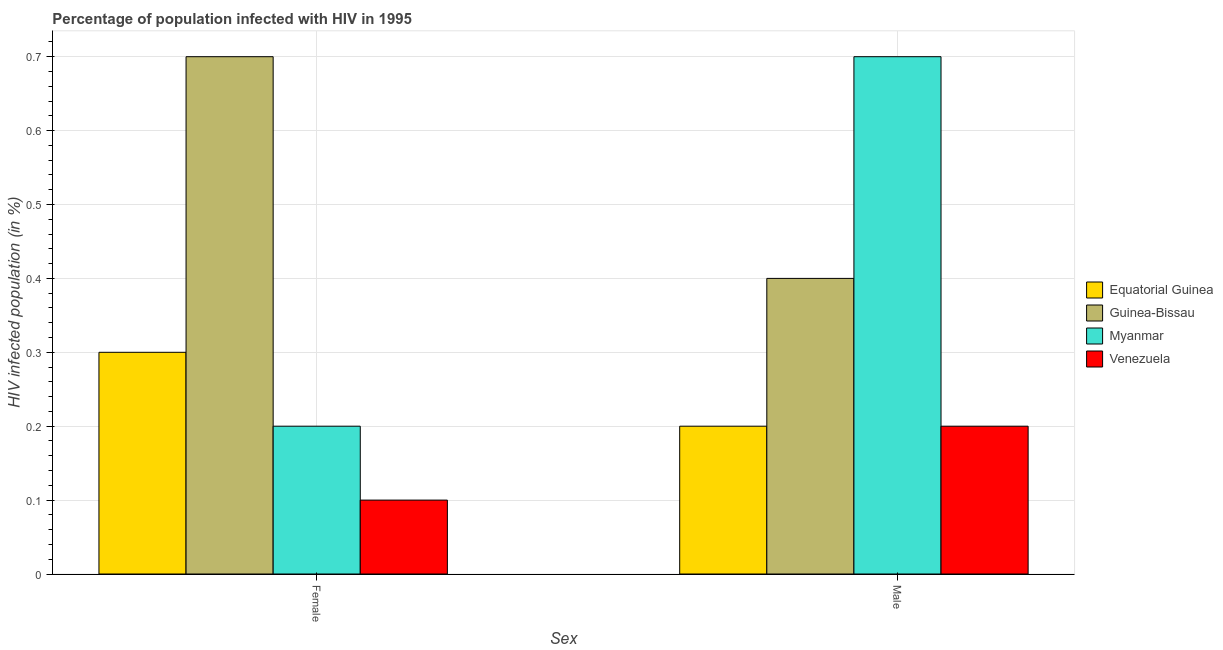Are the number of bars per tick equal to the number of legend labels?
Offer a terse response. Yes. What is the percentage of females who are infected with hiv in Venezuela?
Your answer should be compact. 0.1. Across all countries, what is the maximum percentage of males who are infected with hiv?
Provide a succinct answer. 0.7. Across all countries, what is the minimum percentage of females who are infected with hiv?
Your response must be concise. 0.1. In which country was the percentage of females who are infected with hiv maximum?
Your answer should be compact. Guinea-Bissau. In which country was the percentage of males who are infected with hiv minimum?
Make the answer very short. Equatorial Guinea. What is the difference between the percentage of females who are infected with hiv in Myanmar and that in Equatorial Guinea?
Give a very brief answer. -0.1. What is the difference between the percentage of males who are infected with hiv in Myanmar and the percentage of females who are infected with hiv in Equatorial Guinea?
Offer a terse response. 0.4. What is the average percentage of males who are infected with hiv per country?
Ensure brevity in your answer.  0.38. In how many countries, is the percentage of males who are infected with hiv greater than 0.46 %?
Offer a very short reply. 1. In how many countries, is the percentage of males who are infected with hiv greater than the average percentage of males who are infected with hiv taken over all countries?
Your answer should be very brief. 2. What does the 4th bar from the left in Male represents?
Your answer should be compact. Venezuela. What does the 2nd bar from the right in Male represents?
Provide a short and direct response. Myanmar. What is the difference between two consecutive major ticks on the Y-axis?
Your answer should be compact. 0.1. Are the values on the major ticks of Y-axis written in scientific E-notation?
Give a very brief answer. No. Does the graph contain any zero values?
Make the answer very short. No. How many legend labels are there?
Give a very brief answer. 4. How are the legend labels stacked?
Provide a short and direct response. Vertical. What is the title of the graph?
Keep it short and to the point. Percentage of population infected with HIV in 1995. Does "Palau" appear as one of the legend labels in the graph?
Provide a succinct answer. No. What is the label or title of the X-axis?
Make the answer very short. Sex. What is the label or title of the Y-axis?
Your answer should be very brief. HIV infected population (in %). What is the HIV infected population (in %) in Guinea-Bissau in Female?
Offer a very short reply. 0.7. What is the HIV infected population (in %) in Equatorial Guinea in Male?
Your answer should be very brief. 0.2. What is the HIV infected population (in %) of Myanmar in Male?
Keep it short and to the point. 0.7. What is the HIV infected population (in %) of Venezuela in Male?
Ensure brevity in your answer.  0.2. Across all Sex, what is the maximum HIV infected population (in %) in Equatorial Guinea?
Offer a very short reply. 0.3. Across all Sex, what is the maximum HIV infected population (in %) of Myanmar?
Your answer should be very brief. 0.7. Across all Sex, what is the minimum HIV infected population (in %) in Equatorial Guinea?
Make the answer very short. 0.2. Across all Sex, what is the minimum HIV infected population (in %) in Guinea-Bissau?
Offer a terse response. 0.4. Across all Sex, what is the minimum HIV infected population (in %) of Venezuela?
Ensure brevity in your answer.  0.1. What is the total HIV infected population (in %) in Equatorial Guinea in the graph?
Give a very brief answer. 0.5. What is the total HIV infected population (in %) in Myanmar in the graph?
Offer a terse response. 0.9. What is the difference between the HIV infected population (in %) in Guinea-Bissau in Female and that in Male?
Your answer should be compact. 0.3. What is the difference between the HIV infected population (in %) in Equatorial Guinea in Female and the HIV infected population (in %) in Myanmar in Male?
Provide a succinct answer. -0.4. What is the difference between the HIV infected population (in %) of Guinea-Bissau in Female and the HIV infected population (in %) of Myanmar in Male?
Your answer should be compact. 0. What is the difference between the HIV infected population (in %) of Guinea-Bissau in Female and the HIV infected population (in %) of Venezuela in Male?
Your response must be concise. 0.5. What is the average HIV infected population (in %) in Equatorial Guinea per Sex?
Give a very brief answer. 0.25. What is the average HIV infected population (in %) in Guinea-Bissau per Sex?
Provide a succinct answer. 0.55. What is the average HIV infected population (in %) in Myanmar per Sex?
Provide a succinct answer. 0.45. What is the average HIV infected population (in %) of Venezuela per Sex?
Offer a very short reply. 0.15. What is the difference between the HIV infected population (in %) of Equatorial Guinea and HIV infected population (in %) of Venezuela in Female?
Your response must be concise. 0.2. What is the difference between the HIV infected population (in %) of Guinea-Bissau and HIV infected population (in %) of Myanmar in Female?
Provide a succinct answer. 0.5. What is the difference between the HIV infected population (in %) of Myanmar and HIV infected population (in %) of Venezuela in Female?
Give a very brief answer. 0.1. What is the difference between the HIV infected population (in %) of Equatorial Guinea and HIV infected population (in %) of Myanmar in Male?
Provide a succinct answer. -0.5. What is the difference between the HIV infected population (in %) in Guinea-Bissau and HIV infected population (in %) in Myanmar in Male?
Your response must be concise. -0.3. What is the difference between the HIV infected population (in %) of Guinea-Bissau and HIV infected population (in %) of Venezuela in Male?
Offer a terse response. 0.2. What is the ratio of the HIV infected population (in %) of Equatorial Guinea in Female to that in Male?
Your response must be concise. 1.5. What is the ratio of the HIV infected population (in %) of Guinea-Bissau in Female to that in Male?
Keep it short and to the point. 1.75. What is the ratio of the HIV infected population (in %) of Myanmar in Female to that in Male?
Ensure brevity in your answer.  0.29. What is the ratio of the HIV infected population (in %) in Venezuela in Female to that in Male?
Your response must be concise. 0.5. What is the difference between the highest and the second highest HIV infected population (in %) of Equatorial Guinea?
Provide a succinct answer. 0.1. What is the difference between the highest and the second highest HIV infected population (in %) in Myanmar?
Ensure brevity in your answer.  0.5. What is the difference between the highest and the lowest HIV infected population (in %) of Guinea-Bissau?
Keep it short and to the point. 0.3. 